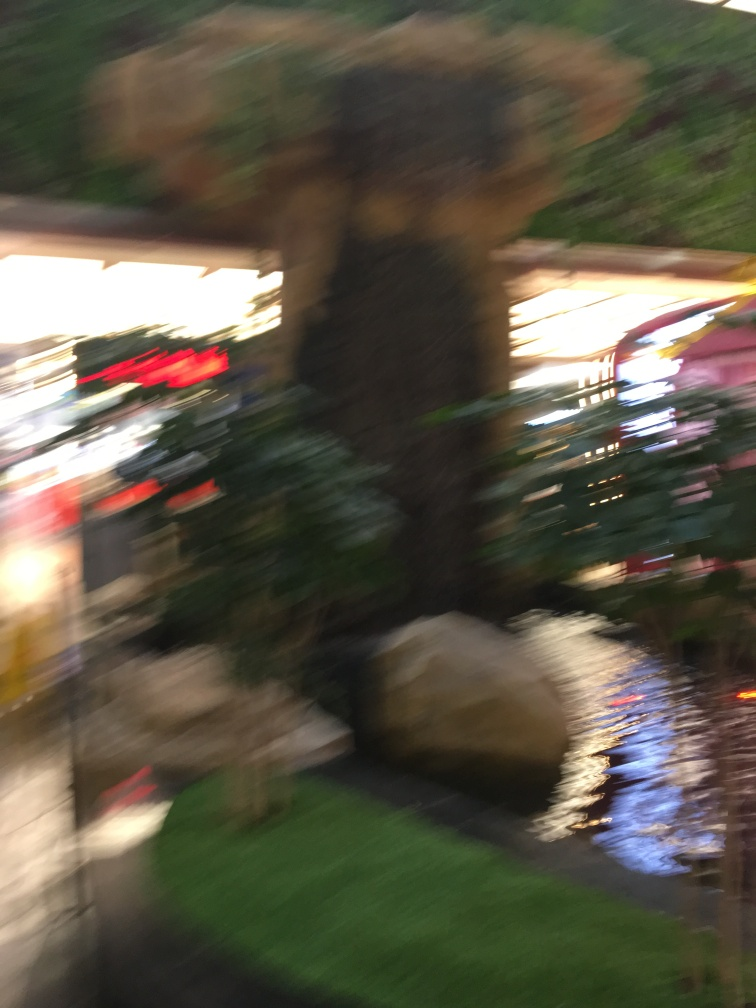Could there be any artistic reason for this level of blur in a photo? Certainly, photographers sometimes employ motion blur intentionally to create a sense of movement or to convey the passage of time. It can also add a layer of abstraction to a scene, focusing on colors and forms rather than sharp details, appealing to viewers' emotions and imagination. 